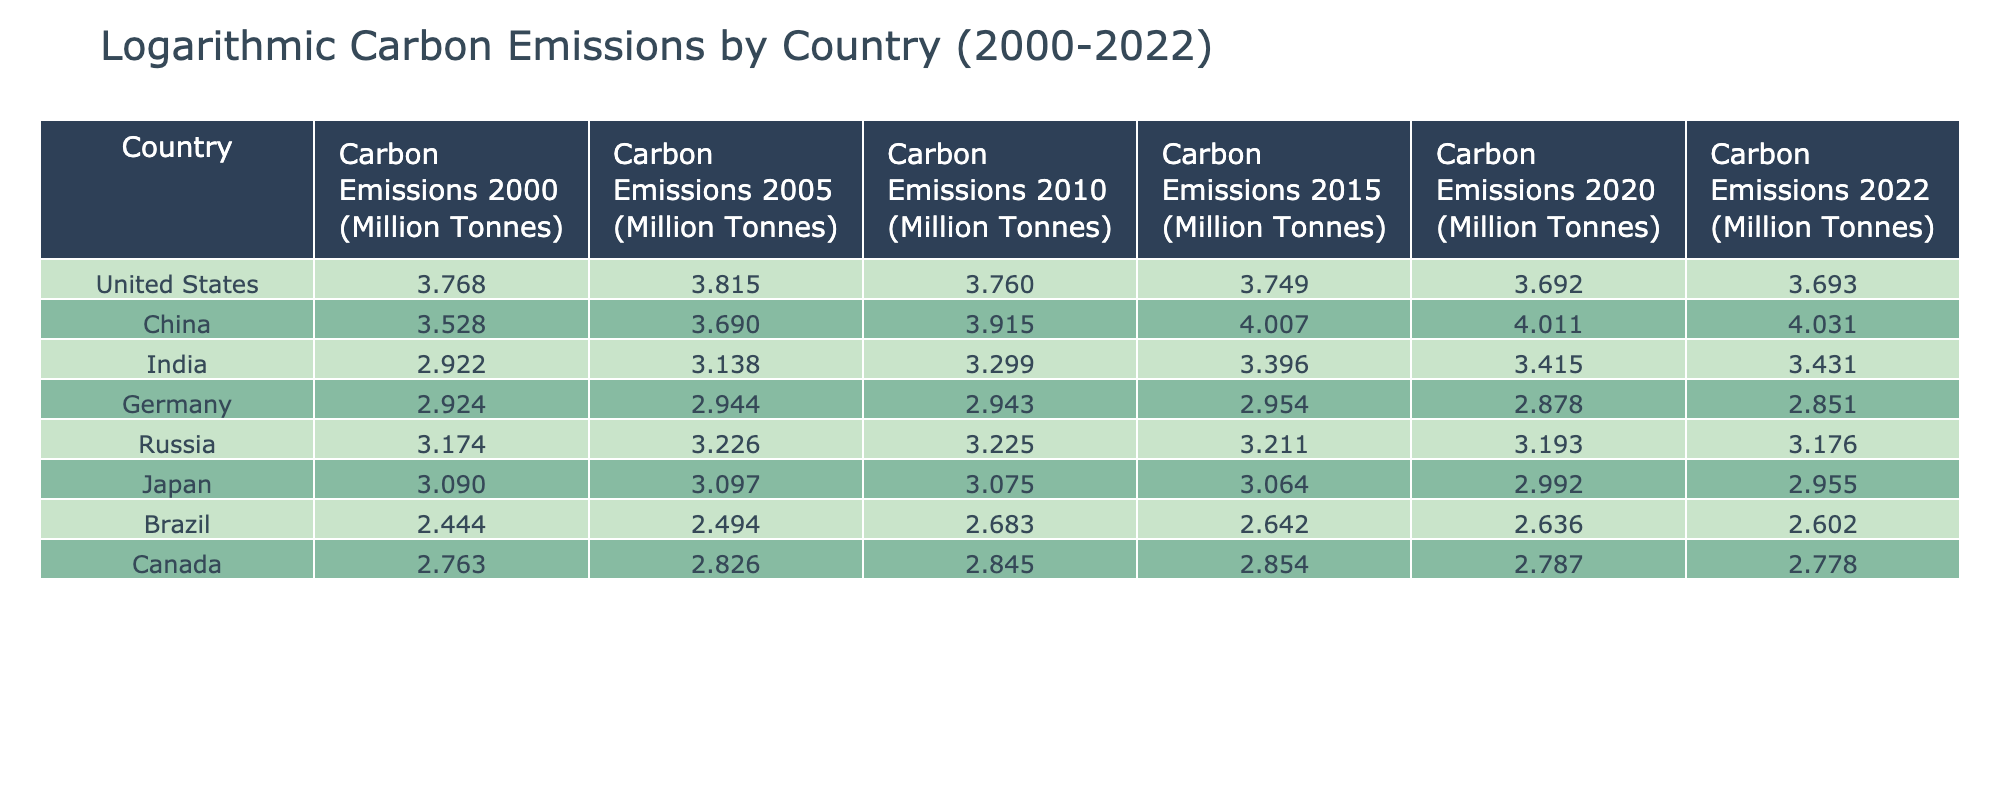What was the carbon emission in China in 2010? The table shows that the carbon emissions in China in 2010 were 8230 million tonnes, presented in logarithmic values. This can be directly retrieved from the column that lists emissions for each country in that specific year.
Answer: 8230 Which country had the lowest carbon emissions in 2022? Reviewing the column for carbon emissions in 2022, Brazil has the lowest value of 400 million tonnes compared to other countries. This is determined by scanning through all the values in that column and identifying the minimum.
Answer: Brazil What was the percentage decrease in carbon emissions from the United States from 2000 to 2022? The carbon emissions in the United States decreased from 5860 million tonnes in 2000 to 4934 million tonnes in 2022. To find the percentage decrease, the formula is ((5860 - 4934) / 5860) * 100. This calculates to about a 15.7% decrease.
Answer: 15.7% Did Germany’s carbon emissions in 2015 exceed those in 2020? Looking at the emissions for Germany, in 2015 the value was 900 million tonnes and in 2020 it was 755 million tonnes. Since 900 is greater than 755, the answer to this question is yes.
Answer: Yes What was the average carbon emission for India from 2000 to 2022? To calculate the average, first add the emissions for India across all years: 835 + 1374 + 1989 + 2487 + 2600 + 2700 equals 10385 million tonnes. Then, divide this sum by the number of years (6): 10385 / 6 = approximately 1730.83.
Answer: 1730.83 Which two countries had an increase in carbon emissions from 2000 to 2022? By comparing emissions for each country from 2000 to 2022, we find that only China and India showed an increase. China increased from 3373 to 10751 million tonnes, and India increased from 835 to 2700 million tonnes. This requires checking the difference for each country over the specified years.
Answer: China and India What was the change in carbon emissions for Russia from 2000 to 2022? The carbon emissions in Russia were 1493 million tonnes in 2000 and decreased to 1500 million tonnes in 2022. The change is computed as 1500 - 1493 = 7 million tonnes, which indicates an increase, but slight overall it remains relatively stable through the years.
Answer: 7 In which year did Japan experience its highest carbon emissions according to the table? Scanning through the emissions data for Japan, the highest value is 1251 million tonnes in 2005. This year is identified by examining each year’s values and determining which is the largest.
Answer: 2005 How many countries had carbon emissions above 5000 million tonnes in 2022? Looking at the emissions for 2022, only China (10751 million tonnes) and the United States (4934 million tonnes) are above 5000 million tonnes, making a total of 1 country. This involves a straightforward count of those values that exceed the threshold.
Answer: 1 